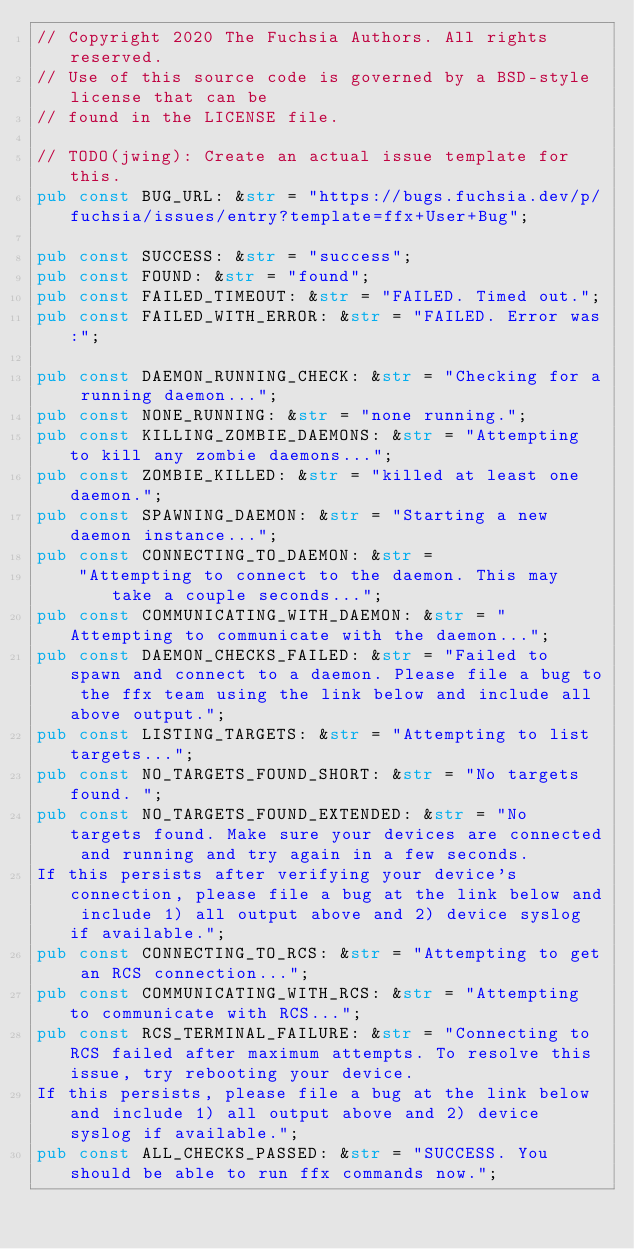Convert code to text. <code><loc_0><loc_0><loc_500><loc_500><_Rust_>// Copyright 2020 The Fuchsia Authors. All rights reserved.
// Use of this source code is governed by a BSD-style license that can be
// found in the LICENSE file.

// TODO(jwing): Create an actual issue template for this.
pub const BUG_URL: &str = "https://bugs.fuchsia.dev/p/fuchsia/issues/entry?template=ffx+User+Bug";

pub const SUCCESS: &str = "success";
pub const FOUND: &str = "found";
pub const FAILED_TIMEOUT: &str = "FAILED. Timed out.";
pub const FAILED_WITH_ERROR: &str = "FAILED. Error was:";

pub const DAEMON_RUNNING_CHECK: &str = "Checking for a running daemon...";
pub const NONE_RUNNING: &str = "none running.";
pub const KILLING_ZOMBIE_DAEMONS: &str = "Attempting to kill any zombie daemons...";
pub const ZOMBIE_KILLED: &str = "killed at least one daemon.";
pub const SPAWNING_DAEMON: &str = "Starting a new daemon instance...";
pub const CONNECTING_TO_DAEMON: &str =
    "Attempting to connect to the daemon. This may take a couple seconds...";
pub const COMMUNICATING_WITH_DAEMON: &str = "Attempting to communicate with the daemon...";
pub const DAEMON_CHECKS_FAILED: &str = "Failed to spawn and connect to a daemon. Please file a bug to the ffx team using the link below and include all above output.";
pub const LISTING_TARGETS: &str = "Attempting to list targets...";
pub const NO_TARGETS_FOUND_SHORT: &str = "No targets found. ";
pub const NO_TARGETS_FOUND_EXTENDED: &str = "No targets found. Make sure your devices are connected and running and try again in a few seconds.
If this persists after verifying your device's connection, please file a bug at the link below and include 1) all output above and 2) device syslog if available.";
pub const CONNECTING_TO_RCS: &str = "Attempting to get an RCS connection...";
pub const COMMUNICATING_WITH_RCS: &str = "Attempting to communicate with RCS...";
pub const RCS_TERMINAL_FAILURE: &str = "Connecting to RCS failed after maximum attempts. To resolve this issue, try rebooting your device.
If this persists, please file a bug at the link below and include 1) all output above and 2) device syslog if available.";
pub const ALL_CHECKS_PASSED: &str = "SUCCESS. You should be able to run ffx commands now.";
</code> 